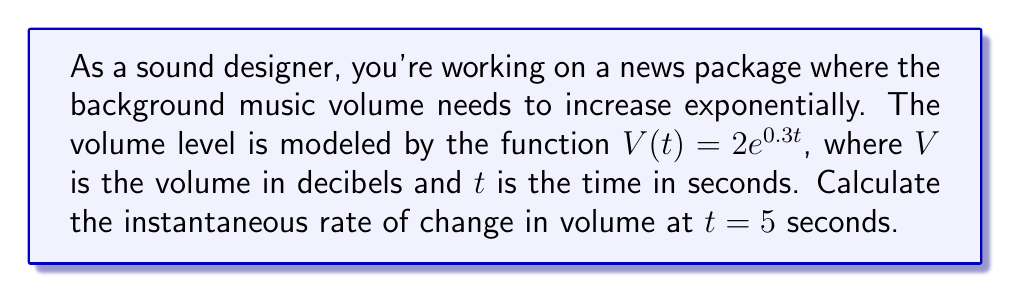Help me with this question. To find the instantaneous rate of change, we need to calculate the derivative of the volume function $V(t)$ and evaluate it at $t = 5$.

1) The given function is $V(t) = 2e^{0.3t}$

2) To find the derivative, we use the chain rule:
   $$\frac{dV}{dt} = 2 \cdot \frac{d}{dt}(e^{0.3t})$$
   $$\frac{dV}{dt} = 2 \cdot 0.3 \cdot e^{0.3t}$$
   $$\frac{dV}{dt} = 0.6e^{0.3t}$$

3) Now, we evaluate this derivative at $t = 5$:
   $$\frac{dV}{dt}|_{t=5} = 0.6e^{0.3(5)}$$
   $$\frac{dV}{dt}|_{t=5} = 0.6e^{1.5}$$

4) Calculate the value:
   $$\frac{dV}{dt}|_{t=5} = 0.6 \cdot 4.4817 \approx 2.6890$$

The rate of change at $t = 5$ seconds is approximately 2.6890 decibels per second.
Answer: 2.6890 dB/s 